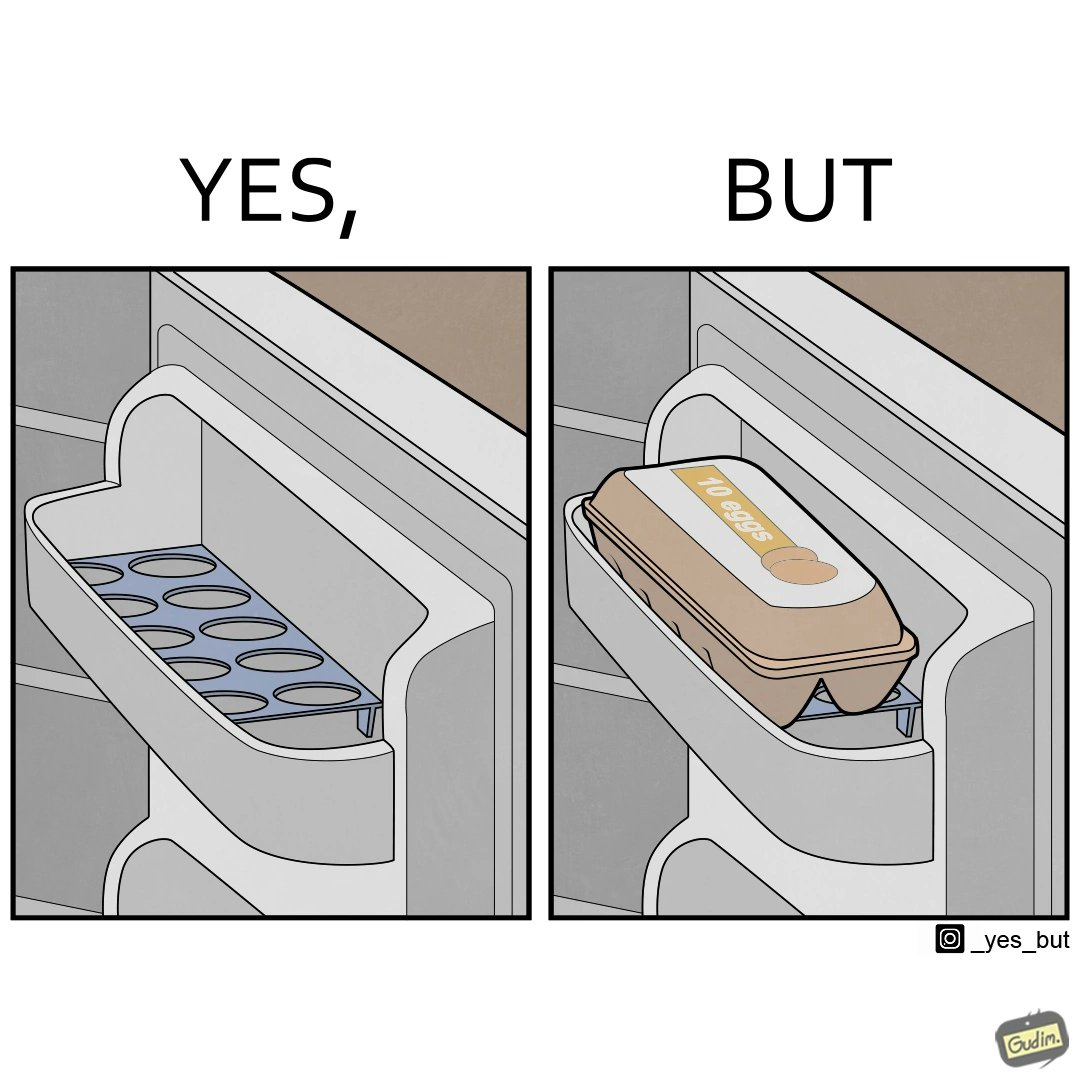Explain the humor or irony in this image. The images are funny since the show how even though refrigerator manufacturers design in-built egg trays, they are of no use to users who choose to put their entire box of eggs in the refrigerator 